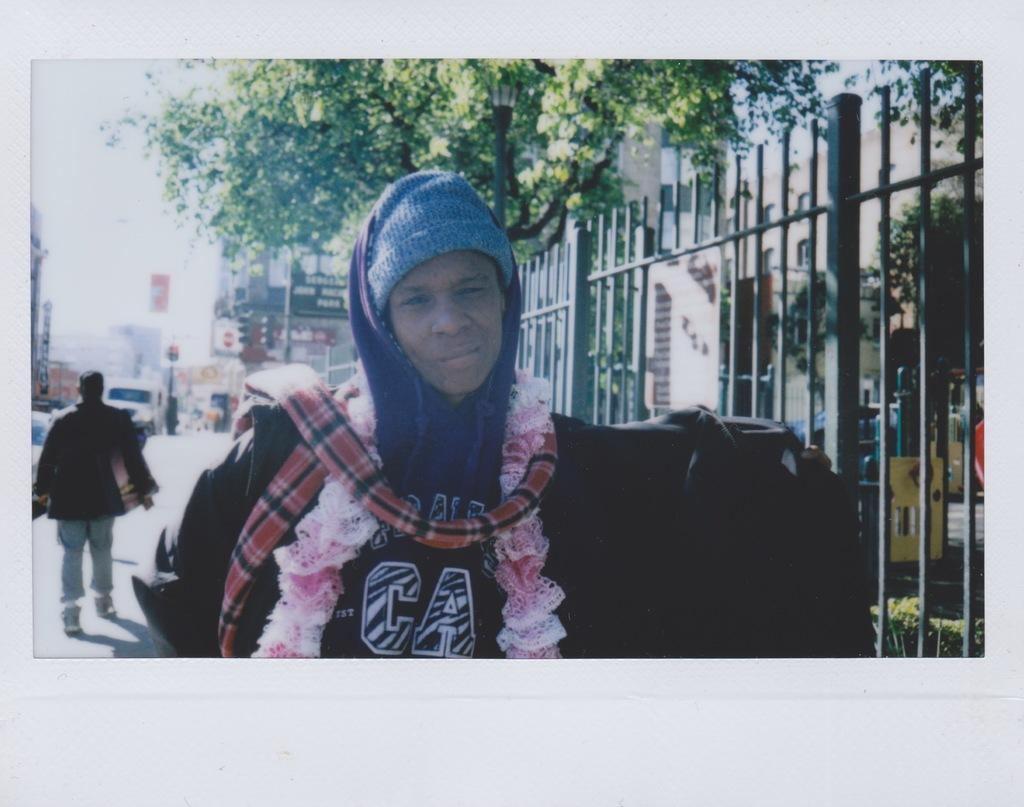<image>
Create a compact narrative representing the image presented. Someone stands on a city street wearing warm clothes including a jacket with CA on it. 